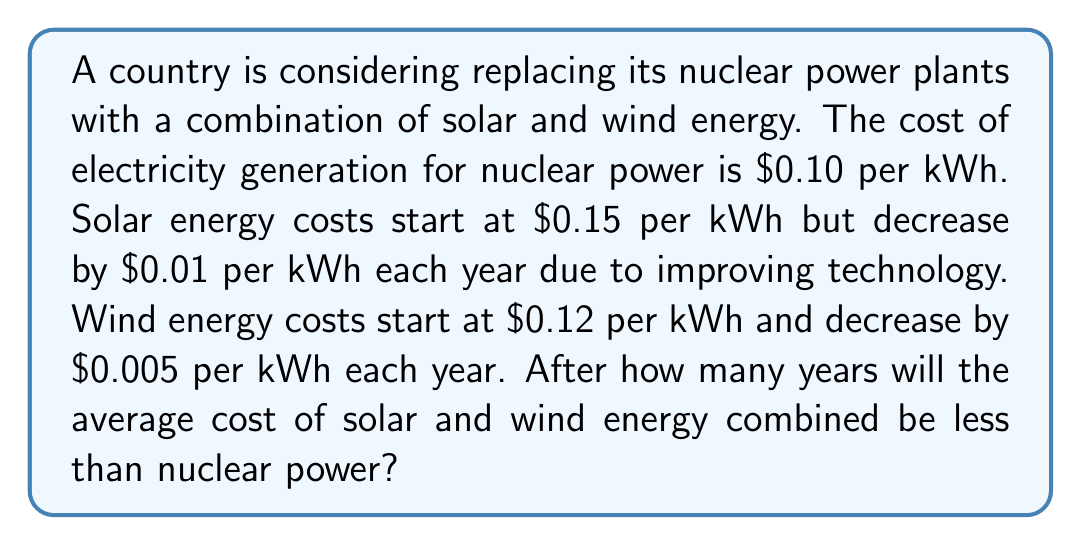Help me with this question. Let's approach this step-by-step:

1) Let $n$ be the number of years.

2) The cost of solar energy after $n$ years:
   $S_n = 0.15 - 0.01n$

3) The cost of wind energy after $n$ years:
   $W_n = 0.12 - 0.005n$

4) The average cost of solar and wind energy after $n$ years:
   $$A_n = \frac{S_n + W_n}{2} = \frac{(0.15 - 0.01n) + (0.12 - 0.005n)}{2}$$

5) Simplify:
   $$A_n = \frac{0.27 - 0.015n}{2} = 0.135 - 0.0075n$$

6) We want to find when this average cost is less than nuclear power:
   $$0.135 - 0.0075n < 0.10$$

7) Solve the inequality:
   $$-0.0075n < -0.035$$
   $$0.0075n > 0.035$$
   $$n > \frac{0.035}{0.0075} = 4.67$$

8) Since $n$ must be a whole number of years, we round up to 5.
Answer: 5 years 